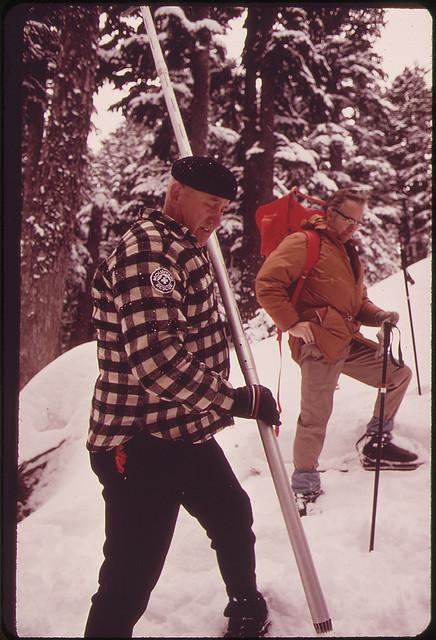What are the people holding?
Quick response, please. Poles. What is the ground covered with?
Write a very short answer. Snow. Is either man wearing a hat?
Keep it brief. Yes. 